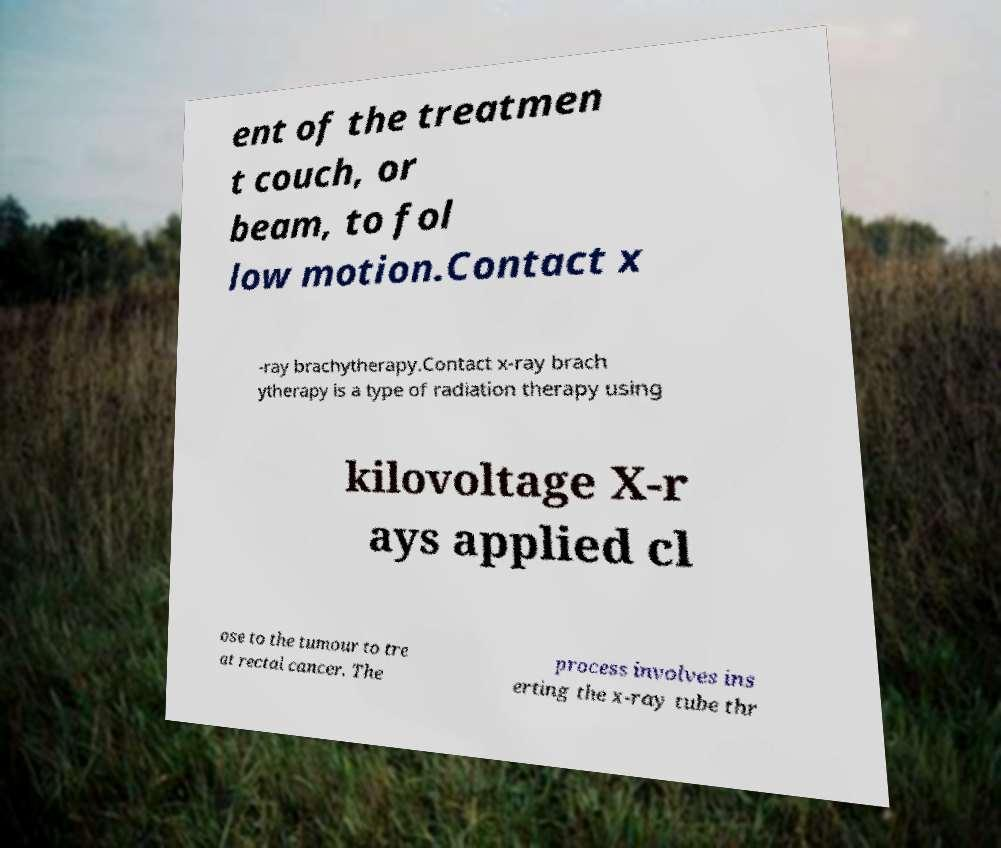Can you read and provide the text displayed in the image?This photo seems to have some interesting text. Can you extract and type it out for me? ent of the treatmen t couch, or beam, to fol low motion.Contact x -ray brachytherapy.Contact x-ray brach ytherapy is a type of radiation therapy using kilovoltage X-r ays applied cl ose to the tumour to tre at rectal cancer. The process involves ins erting the x-ray tube thr 